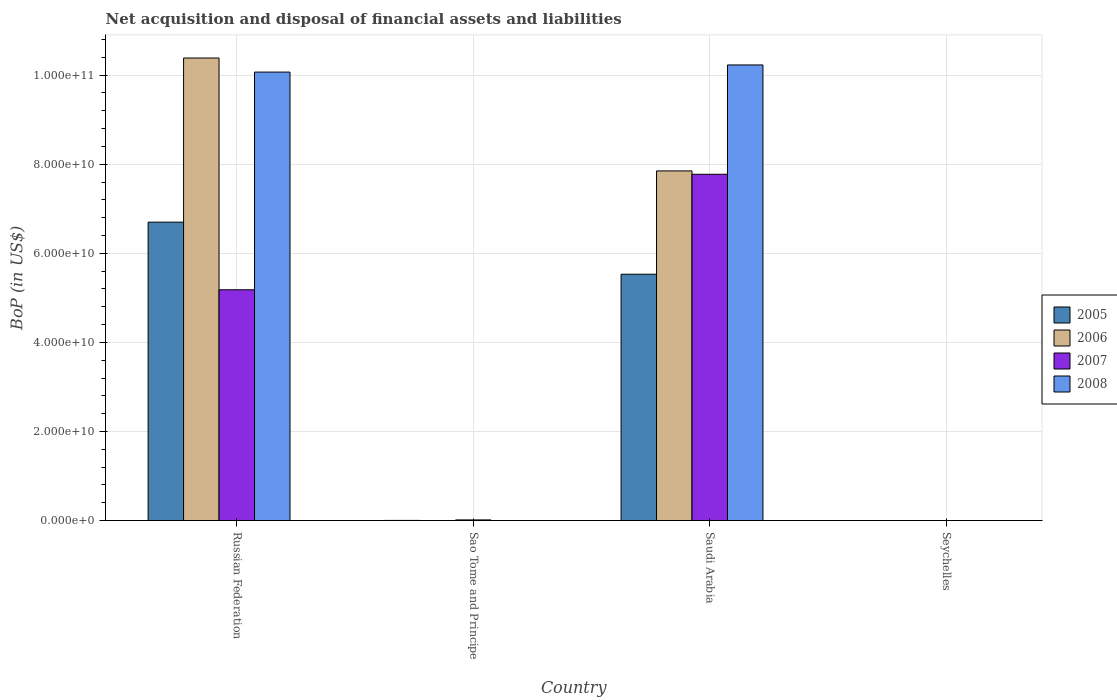What is the label of the 1st group of bars from the left?
Provide a short and direct response. Russian Federation. What is the Balance of Payments in 2008 in Seychelles?
Provide a succinct answer. 0. Across all countries, what is the maximum Balance of Payments in 2007?
Offer a terse response. 7.78e+1. In which country was the Balance of Payments in 2007 maximum?
Make the answer very short. Saudi Arabia. What is the total Balance of Payments in 2008 in the graph?
Offer a very short reply. 2.03e+11. What is the difference between the Balance of Payments in 2007 in Russian Federation and that in Sao Tome and Principe?
Keep it short and to the point. 5.17e+1. What is the difference between the Balance of Payments in 2005 in Russian Federation and the Balance of Payments in 2008 in Sao Tome and Principe?
Offer a terse response. 6.70e+1. What is the average Balance of Payments in 2006 per country?
Give a very brief answer. 4.56e+1. What is the difference between the Balance of Payments of/in 2007 and Balance of Payments of/in 2008 in Saudi Arabia?
Your answer should be very brief. -2.45e+1. In how many countries, is the Balance of Payments in 2005 greater than 48000000000 US$?
Keep it short and to the point. 2. What is the ratio of the Balance of Payments in 2007 in Russian Federation to that in Saudi Arabia?
Provide a succinct answer. 0.67. Is the difference between the Balance of Payments in 2007 in Russian Federation and Saudi Arabia greater than the difference between the Balance of Payments in 2008 in Russian Federation and Saudi Arabia?
Offer a terse response. No. What is the difference between the highest and the second highest Balance of Payments in 2007?
Provide a short and direct response. 7.76e+1. What is the difference between the highest and the lowest Balance of Payments in 2007?
Your response must be concise. 7.78e+1. In how many countries, is the Balance of Payments in 2006 greater than the average Balance of Payments in 2006 taken over all countries?
Offer a very short reply. 2. Is the sum of the Balance of Payments in 2008 in Russian Federation and Saudi Arabia greater than the maximum Balance of Payments in 2006 across all countries?
Offer a very short reply. Yes. Is it the case that in every country, the sum of the Balance of Payments in 2007 and Balance of Payments in 2006 is greater than the sum of Balance of Payments in 2008 and Balance of Payments in 2005?
Your response must be concise. No. Is it the case that in every country, the sum of the Balance of Payments in 2006 and Balance of Payments in 2005 is greater than the Balance of Payments in 2007?
Provide a short and direct response. No. Are all the bars in the graph horizontal?
Offer a terse response. No. Are the values on the major ticks of Y-axis written in scientific E-notation?
Offer a terse response. Yes. Does the graph contain any zero values?
Offer a terse response. Yes. How many legend labels are there?
Keep it short and to the point. 4. How are the legend labels stacked?
Offer a terse response. Vertical. What is the title of the graph?
Your response must be concise. Net acquisition and disposal of financial assets and liabilities. What is the label or title of the X-axis?
Provide a short and direct response. Country. What is the label or title of the Y-axis?
Make the answer very short. BoP (in US$). What is the BoP (in US$) of 2005 in Russian Federation?
Offer a very short reply. 6.70e+1. What is the BoP (in US$) of 2006 in Russian Federation?
Offer a terse response. 1.04e+11. What is the BoP (in US$) in 2007 in Russian Federation?
Your answer should be compact. 5.18e+1. What is the BoP (in US$) of 2008 in Russian Federation?
Keep it short and to the point. 1.01e+11. What is the BoP (in US$) of 2005 in Sao Tome and Principe?
Provide a short and direct response. 3.62e+07. What is the BoP (in US$) of 2007 in Sao Tome and Principe?
Provide a short and direct response. 1.50e+08. What is the BoP (in US$) of 2008 in Sao Tome and Principe?
Offer a very short reply. 0. What is the BoP (in US$) of 2005 in Saudi Arabia?
Make the answer very short. 5.53e+1. What is the BoP (in US$) in 2006 in Saudi Arabia?
Your answer should be compact. 7.85e+1. What is the BoP (in US$) in 2007 in Saudi Arabia?
Offer a terse response. 7.78e+1. What is the BoP (in US$) in 2008 in Saudi Arabia?
Provide a succinct answer. 1.02e+11. What is the BoP (in US$) of 2006 in Seychelles?
Provide a short and direct response. 0. What is the BoP (in US$) in 2008 in Seychelles?
Provide a succinct answer. 0. Across all countries, what is the maximum BoP (in US$) in 2005?
Ensure brevity in your answer.  6.70e+1. Across all countries, what is the maximum BoP (in US$) in 2006?
Your answer should be compact. 1.04e+11. Across all countries, what is the maximum BoP (in US$) of 2007?
Provide a short and direct response. 7.78e+1. Across all countries, what is the maximum BoP (in US$) of 2008?
Your response must be concise. 1.02e+11. Across all countries, what is the minimum BoP (in US$) in 2005?
Give a very brief answer. 0. Across all countries, what is the minimum BoP (in US$) of 2006?
Make the answer very short. 0. Across all countries, what is the minimum BoP (in US$) of 2007?
Offer a terse response. 0. Across all countries, what is the minimum BoP (in US$) of 2008?
Ensure brevity in your answer.  0. What is the total BoP (in US$) of 2005 in the graph?
Keep it short and to the point. 1.22e+11. What is the total BoP (in US$) in 2006 in the graph?
Provide a short and direct response. 1.82e+11. What is the total BoP (in US$) in 2007 in the graph?
Provide a short and direct response. 1.30e+11. What is the total BoP (in US$) in 2008 in the graph?
Your answer should be very brief. 2.03e+11. What is the difference between the BoP (in US$) of 2005 in Russian Federation and that in Sao Tome and Principe?
Your answer should be very brief. 6.70e+1. What is the difference between the BoP (in US$) of 2007 in Russian Federation and that in Sao Tome and Principe?
Your response must be concise. 5.17e+1. What is the difference between the BoP (in US$) of 2005 in Russian Federation and that in Saudi Arabia?
Your response must be concise. 1.17e+1. What is the difference between the BoP (in US$) of 2006 in Russian Federation and that in Saudi Arabia?
Your response must be concise. 2.53e+1. What is the difference between the BoP (in US$) in 2007 in Russian Federation and that in Saudi Arabia?
Ensure brevity in your answer.  -2.59e+1. What is the difference between the BoP (in US$) in 2008 in Russian Federation and that in Saudi Arabia?
Offer a very short reply. -1.60e+09. What is the difference between the BoP (in US$) of 2005 in Sao Tome and Principe and that in Saudi Arabia?
Make the answer very short. -5.53e+1. What is the difference between the BoP (in US$) of 2007 in Sao Tome and Principe and that in Saudi Arabia?
Your response must be concise. -7.76e+1. What is the difference between the BoP (in US$) of 2005 in Russian Federation and the BoP (in US$) of 2007 in Sao Tome and Principe?
Make the answer very short. 6.68e+1. What is the difference between the BoP (in US$) in 2006 in Russian Federation and the BoP (in US$) in 2007 in Sao Tome and Principe?
Your response must be concise. 1.04e+11. What is the difference between the BoP (in US$) in 2005 in Russian Federation and the BoP (in US$) in 2006 in Saudi Arabia?
Offer a terse response. -1.15e+1. What is the difference between the BoP (in US$) in 2005 in Russian Federation and the BoP (in US$) in 2007 in Saudi Arabia?
Your answer should be compact. -1.08e+1. What is the difference between the BoP (in US$) of 2005 in Russian Federation and the BoP (in US$) of 2008 in Saudi Arabia?
Your answer should be compact. -3.53e+1. What is the difference between the BoP (in US$) of 2006 in Russian Federation and the BoP (in US$) of 2007 in Saudi Arabia?
Your response must be concise. 2.61e+1. What is the difference between the BoP (in US$) of 2006 in Russian Federation and the BoP (in US$) of 2008 in Saudi Arabia?
Your answer should be compact. 1.56e+09. What is the difference between the BoP (in US$) in 2007 in Russian Federation and the BoP (in US$) in 2008 in Saudi Arabia?
Keep it short and to the point. -5.05e+1. What is the difference between the BoP (in US$) of 2005 in Sao Tome and Principe and the BoP (in US$) of 2006 in Saudi Arabia?
Give a very brief answer. -7.85e+1. What is the difference between the BoP (in US$) of 2005 in Sao Tome and Principe and the BoP (in US$) of 2007 in Saudi Arabia?
Provide a succinct answer. -7.77e+1. What is the difference between the BoP (in US$) of 2005 in Sao Tome and Principe and the BoP (in US$) of 2008 in Saudi Arabia?
Your answer should be compact. -1.02e+11. What is the difference between the BoP (in US$) of 2007 in Sao Tome and Principe and the BoP (in US$) of 2008 in Saudi Arabia?
Offer a very short reply. -1.02e+11. What is the average BoP (in US$) of 2005 per country?
Make the answer very short. 3.06e+1. What is the average BoP (in US$) in 2006 per country?
Your answer should be compact. 4.56e+1. What is the average BoP (in US$) of 2007 per country?
Your answer should be compact. 3.24e+1. What is the average BoP (in US$) in 2008 per country?
Keep it short and to the point. 5.07e+1. What is the difference between the BoP (in US$) of 2005 and BoP (in US$) of 2006 in Russian Federation?
Your answer should be very brief. -3.69e+1. What is the difference between the BoP (in US$) of 2005 and BoP (in US$) of 2007 in Russian Federation?
Your answer should be very brief. 1.52e+1. What is the difference between the BoP (in US$) in 2005 and BoP (in US$) in 2008 in Russian Federation?
Your response must be concise. -3.37e+1. What is the difference between the BoP (in US$) of 2006 and BoP (in US$) of 2007 in Russian Federation?
Provide a short and direct response. 5.20e+1. What is the difference between the BoP (in US$) in 2006 and BoP (in US$) in 2008 in Russian Federation?
Your response must be concise. 3.16e+09. What is the difference between the BoP (in US$) in 2007 and BoP (in US$) in 2008 in Russian Federation?
Offer a terse response. -4.89e+1. What is the difference between the BoP (in US$) in 2005 and BoP (in US$) in 2007 in Sao Tome and Principe?
Offer a terse response. -1.14e+08. What is the difference between the BoP (in US$) in 2005 and BoP (in US$) in 2006 in Saudi Arabia?
Make the answer very short. -2.32e+1. What is the difference between the BoP (in US$) of 2005 and BoP (in US$) of 2007 in Saudi Arabia?
Your answer should be very brief. -2.24e+1. What is the difference between the BoP (in US$) of 2005 and BoP (in US$) of 2008 in Saudi Arabia?
Provide a succinct answer. -4.70e+1. What is the difference between the BoP (in US$) of 2006 and BoP (in US$) of 2007 in Saudi Arabia?
Ensure brevity in your answer.  7.55e+08. What is the difference between the BoP (in US$) of 2006 and BoP (in US$) of 2008 in Saudi Arabia?
Your response must be concise. -2.38e+1. What is the difference between the BoP (in US$) of 2007 and BoP (in US$) of 2008 in Saudi Arabia?
Give a very brief answer. -2.45e+1. What is the ratio of the BoP (in US$) in 2005 in Russian Federation to that in Sao Tome and Principe?
Provide a succinct answer. 1852.28. What is the ratio of the BoP (in US$) in 2007 in Russian Federation to that in Sao Tome and Principe?
Offer a very short reply. 344.37. What is the ratio of the BoP (in US$) of 2005 in Russian Federation to that in Saudi Arabia?
Your response must be concise. 1.21. What is the ratio of the BoP (in US$) of 2006 in Russian Federation to that in Saudi Arabia?
Make the answer very short. 1.32. What is the ratio of the BoP (in US$) in 2007 in Russian Federation to that in Saudi Arabia?
Ensure brevity in your answer.  0.67. What is the ratio of the BoP (in US$) in 2008 in Russian Federation to that in Saudi Arabia?
Give a very brief answer. 0.98. What is the ratio of the BoP (in US$) in 2005 in Sao Tome and Principe to that in Saudi Arabia?
Give a very brief answer. 0. What is the ratio of the BoP (in US$) in 2007 in Sao Tome and Principe to that in Saudi Arabia?
Ensure brevity in your answer.  0. What is the difference between the highest and the second highest BoP (in US$) of 2005?
Keep it short and to the point. 1.17e+1. What is the difference between the highest and the second highest BoP (in US$) of 2007?
Give a very brief answer. 2.59e+1. What is the difference between the highest and the lowest BoP (in US$) in 2005?
Your answer should be compact. 6.70e+1. What is the difference between the highest and the lowest BoP (in US$) in 2006?
Offer a terse response. 1.04e+11. What is the difference between the highest and the lowest BoP (in US$) in 2007?
Your response must be concise. 7.78e+1. What is the difference between the highest and the lowest BoP (in US$) of 2008?
Your answer should be compact. 1.02e+11. 